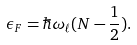Convert formula to latex. <formula><loc_0><loc_0><loc_500><loc_500>\epsilon _ { F } = \hbar { \omega } _ { \ell } ( N - \frac { 1 } { 2 } ) .</formula> 